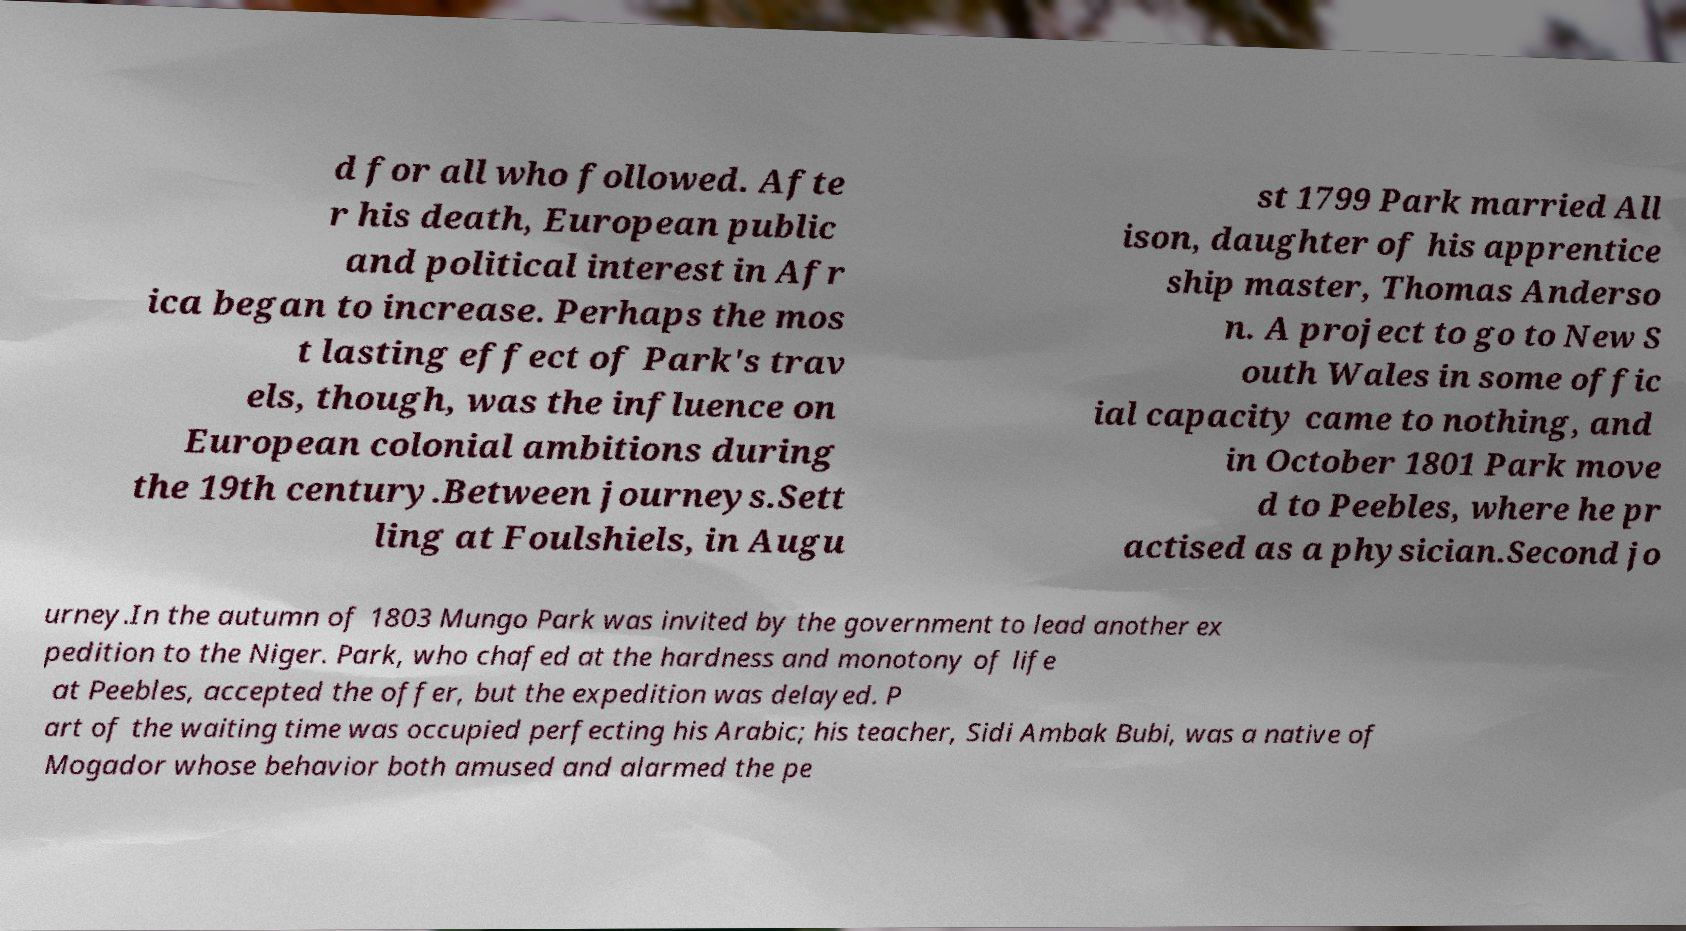Could you extract and type out the text from this image? d for all who followed. Afte r his death, European public and political interest in Afr ica began to increase. Perhaps the mos t lasting effect of Park's trav els, though, was the influence on European colonial ambitions during the 19th century.Between journeys.Sett ling at Foulshiels, in Augu st 1799 Park married All ison, daughter of his apprentice ship master, Thomas Anderso n. A project to go to New S outh Wales in some offic ial capacity came to nothing, and in October 1801 Park move d to Peebles, where he pr actised as a physician.Second jo urney.In the autumn of 1803 Mungo Park was invited by the government to lead another ex pedition to the Niger. Park, who chafed at the hardness and monotony of life at Peebles, accepted the offer, but the expedition was delayed. P art of the waiting time was occupied perfecting his Arabic; his teacher, Sidi Ambak Bubi, was a native of Mogador whose behavior both amused and alarmed the pe 